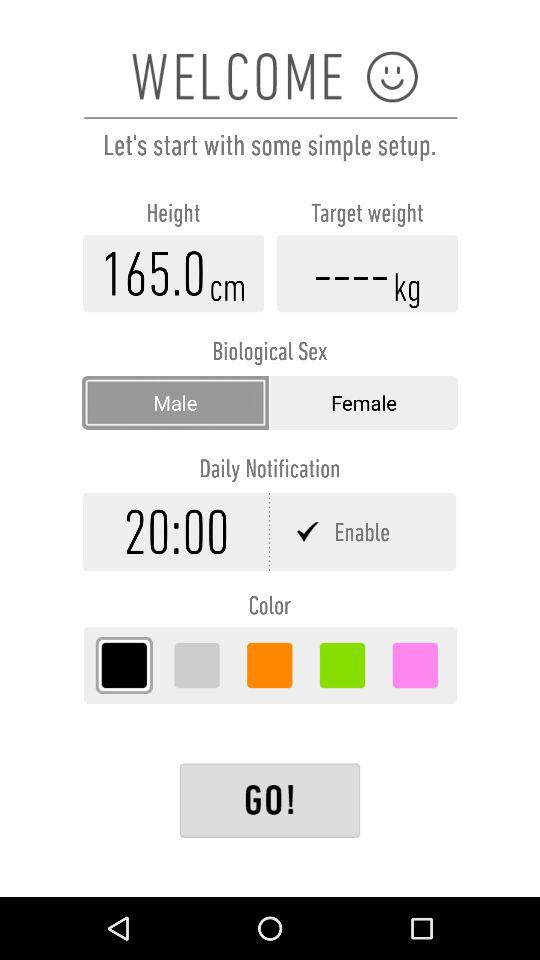What is the selected time? The selected time is 20:00. 